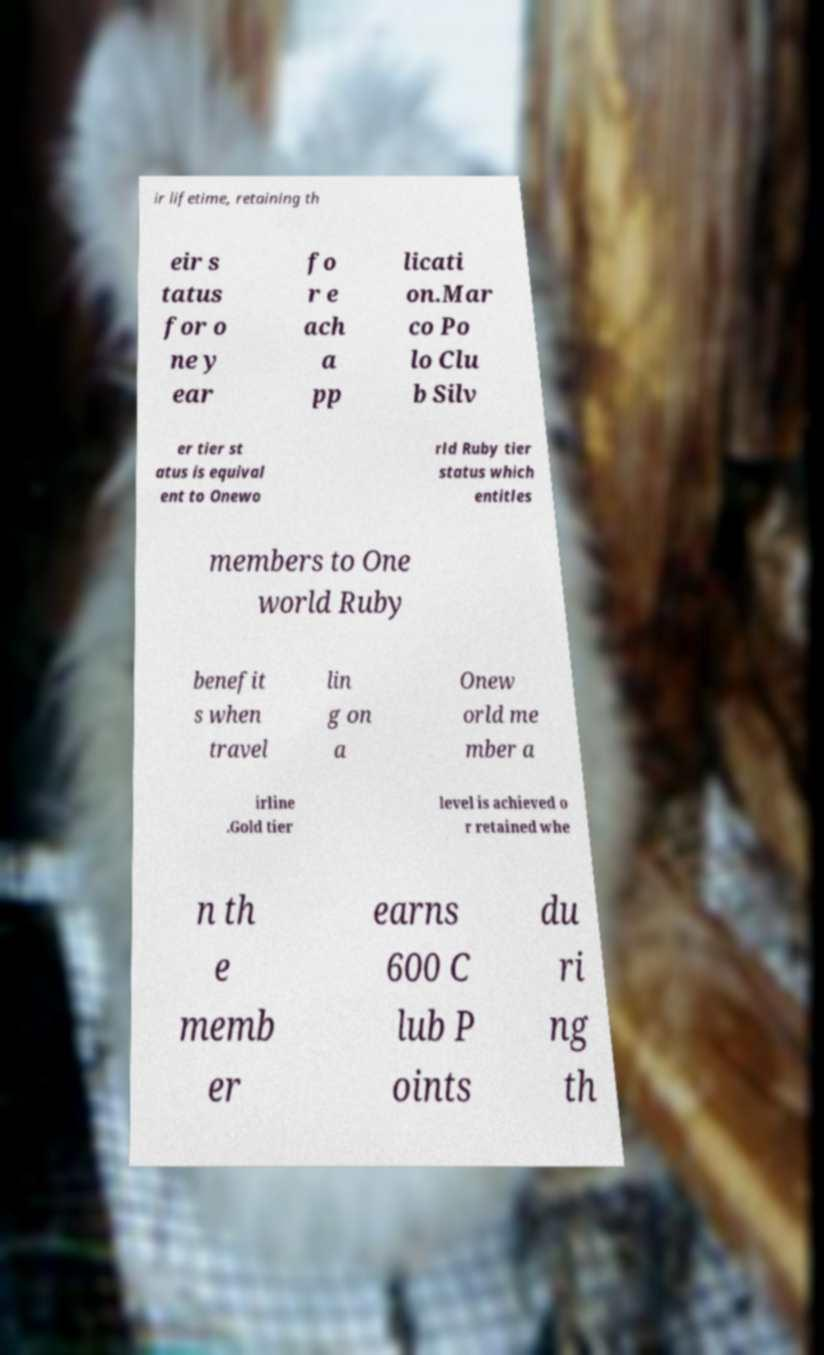Could you assist in decoding the text presented in this image and type it out clearly? ir lifetime, retaining th eir s tatus for o ne y ear fo r e ach a pp licati on.Mar co Po lo Clu b Silv er tier st atus is equival ent to Onewo rld Ruby tier status which entitles members to One world Ruby benefit s when travel lin g on a Onew orld me mber a irline .Gold tier level is achieved o r retained whe n th e memb er earns 600 C lub P oints du ri ng th 